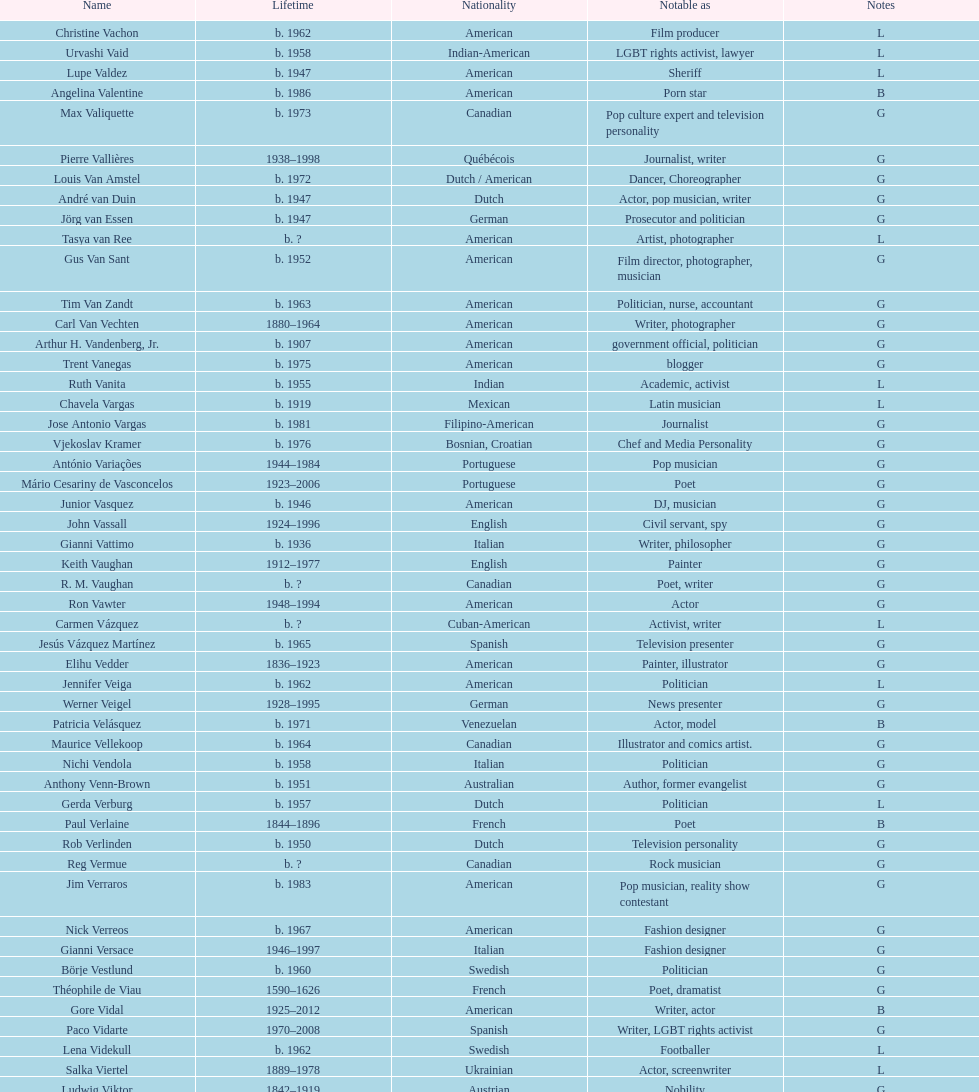Patricia velasquez and ron vawter both had what career? Actor. Would you mind parsing the complete table? {'header': ['Name', 'Lifetime', 'Nationality', 'Notable as', 'Notes'], 'rows': [['Christine Vachon', 'b. 1962', 'American', 'Film producer', 'L'], ['Urvashi Vaid', 'b. 1958', 'Indian-American', 'LGBT rights activist, lawyer', 'L'], ['Lupe Valdez', 'b. 1947', 'American', 'Sheriff', 'L'], ['Angelina Valentine', 'b. 1986', 'American', 'Porn star', 'B'], ['Max Valiquette', 'b. 1973', 'Canadian', 'Pop culture expert and television personality', 'G'], ['Pierre Vallières', '1938–1998', 'Québécois', 'Journalist, writer', 'G'], ['Louis Van Amstel', 'b. 1972', 'Dutch / American', 'Dancer, Choreographer', 'G'], ['André van Duin', 'b. 1947', 'Dutch', 'Actor, pop musician, writer', 'G'], ['Jörg van Essen', 'b. 1947', 'German', 'Prosecutor and politician', 'G'], ['Tasya van Ree', 'b.\xa0?', 'American', 'Artist, photographer', 'L'], ['Gus Van Sant', 'b. 1952', 'American', 'Film director, photographer, musician', 'G'], ['Tim Van Zandt', 'b. 1963', 'American', 'Politician, nurse, accountant', 'G'], ['Carl Van Vechten', '1880–1964', 'American', 'Writer, photographer', 'G'], ['Arthur H. Vandenberg, Jr.', 'b. 1907', 'American', 'government official, politician', 'G'], ['Trent Vanegas', 'b. 1975', 'American', 'blogger', 'G'], ['Ruth Vanita', 'b. 1955', 'Indian', 'Academic, activist', 'L'], ['Chavela Vargas', 'b. 1919', 'Mexican', 'Latin musician', 'L'], ['Jose Antonio Vargas', 'b. 1981', 'Filipino-American', 'Journalist', 'G'], ['Vjekoslav Kramer', 'b. 1976', 'Bosnian, Croatian', 'Chef and Media Personality', 'G'], ['António Variações', '1944–1984', 'Portuguese', 'Pop musician', 'G'], ['Mário Cesariny de Vasconcelos', '1923–2006', 'Portuguese', 'Poet', 'G'], ['Junior Vasquez', 'b. 1946', 'American', 'DJ, musician', 'G'], ['John Vassall', '1924–1996', 'English', 'Civil servant, spy', 'G'], ['Gianni Vattimo', 'b. 1936', 'Italian', 'Writer, philosopher', 'G'], ['Keith Vaughan', '1912–1977', 'English', 'Painter', 'G'], ['R. M. Vaughan', 'b.\xa0?', 'Canadian', 'Poet, writer', 'G'], ['Ron Vawter', '1948–1994', 'American', 'Actor', 'G'], ['Carmen Vázquez', 'b.\xa0?', 'Cuban-American', 'Activist, writer', 'L'], ['Jesús Vázquez Martínez', 'b. 1965', 'Spanish', 'Television presenter', 'G'], ['Elihu Vedder', '1836–1923', 'American', 'Painter, illustrator', 'G'], ['Jennifer Veiga', 'b. 1962', 'American', 'Politician', 'L'], ['Werner Veigel', '1928–1995', 'German', 'News presenter', 'G'], ['Patricia Velásquez', 'b. 1971', 'Venezuelan', 'Actor, model', 'B'], ['Maurice Vellekoop', 'b. 1964', 'Canadian', 'Illustrator and comics artist.', 'G'], ['Nichi Vendola', 'b. 1958', 'Italian', 'Politician', 'G'], ['Anthony Venn-Brown', 'b. 1951', 'Australian', 'Author, former evangelist', 'G'], ['Gerda Verburg', 'b. 1957', 'Dutch', 'Politician', 'L'], ['Paul Verlaine', '1844–1896', 'French', 'Poet', 'B'], ['Rob Verlinden', 'b. 1950', 'Dutch', 'Television personality', 'G'], ['Reg Vermue', 'b.\xa0?', 'Canadian', 'Rock musician', 'G'], ['Jim Verraros', 'b. 1983', 'American', 'Pop musician, reality show contestant', 'G'], ['Nick Verreos', 'b. 1967', 'American', 'Fashion designer', 'G'], ['Gianni Versace', '1946–1997', 'Italian', 'Fashion designer', 'G'], ['Börje Vestlund', 'b. 1960', 'Swedish', 'Politician', 'G'], ['Théophile de Viau', '1590–1626', 'French', 'Poet, dramatist', 'G'], ['Gore Vidal', '1925–2012', 'American', 'Writer, actor', 'B'], ['Paco Vidarte', '1970–2008', 'Spanish', 'Writer, LGBT rights activist', 'G'], ['Lena Videkull', 'b. 1962', 'Swedish', 'Footballer', 'L'], ['Salka Viertel', '1889–1978', 'Ukrainian', 'Actor, screenwriter', 'L'], ['Ludwig Viktor', '1842–1919', 'Austrian', 'Nobility', 'G'], ['Bruce Vilanch', 'b. 1948', 'American', 'Comedy writer, actor', 'G'], ['Tom Villard', '1953–1994', 'American', 'Actor', 'G'], ['José Villarrubia', 'b. 1961', 'American', 'Artist', 'G'], ['Xavier Villaurrutia', '1903–1950', 'Mexican', 'Poet, playwright', 'G'], ["Alain-Philippe Malagnac d'Argens de Villèle", '1950–2000', 'French', 'Aristocrat', 'G'], ['Norah Vincent', 'b.\xa0?', 'American', 'Journalist', 'L'], ['Donald Vining', '1917–1998', 'American', 'Writer', 'G'], ['Luchino Visconti', '1906–1976', 'Italian', 'Filmmaker', 'G'], ['Pavel Vítek', 'b. 1962', 'Czech', 'Pop musician, actor', 'G'], ['Renée Vivien', '1877–1909', 'English', 'Poet', 'L'], ['Claude Vivier', '1948–1983', 'Canadian', '20th century classical composer', 'G'], ['Taylor Vixen', 'b. 1983', 'American', 'Porn star', 'B'], ['Bruce Voeller', '1934–1994', 'American', 'HIV/AIDS researcher', 'G'], ['Paula Vogel', 'b. 1951', 'American', 'Playwright', 'L'], ['Julia Volkova', 'b. 1985', 'Russian', 'Singer', 'B'], ['Jörg van Essen', 'b. 1947', 'German', 'Politician', 'G'], ['Ole von Beust', 'b. 1955', 'German', 'Politician', 'G'], ['Wilhelm von Gloeden', '1856–1931', 'German', 'Photographer', 'G'], ['Rosa von Praunheim', 'b. 1942', 'German', 'Film director', 'G'], ['Kurt von Ruffin', 'b. 1901–1996', 'German', 'Holocaust survivor', 'G'], ['Hella von Sinnen', 'b. 1959', 'German', 'Comedian', 'L'], ['Daniel Vosovic', 'b. 1981', 'American', 'Fashion designer', 'G'], ['Delwin Vriend', 'b. 1966', 'Canadian', 'LGBT rights activist', 'G']]} 